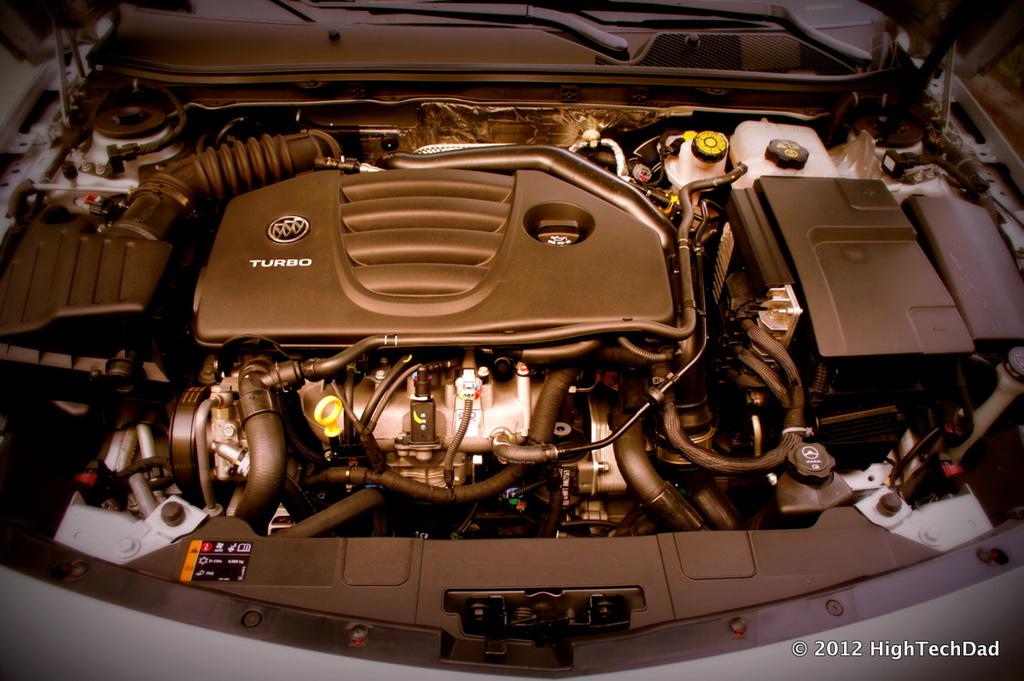What word is written in white on the engine?
Give a very brief answer. Turbo. What is written on the top of the motor cam head?
Keep it short and to the point. Turbo. 